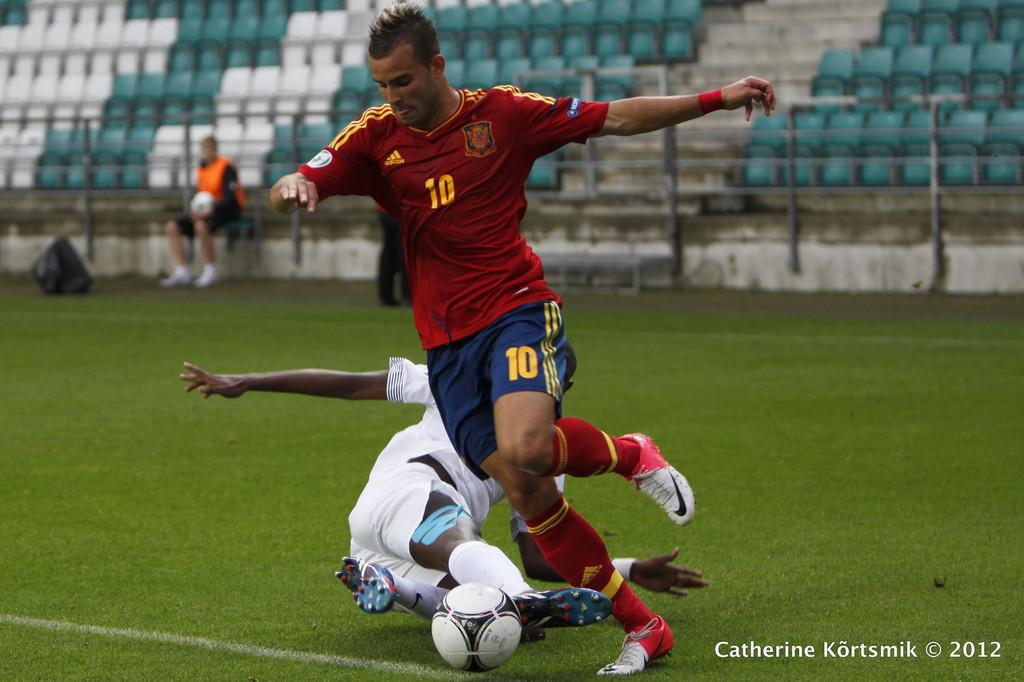When was this photo taken?
Provide a succinct answer. 2012. What number is the player wearing?
Your answer should be very brief. 10. 